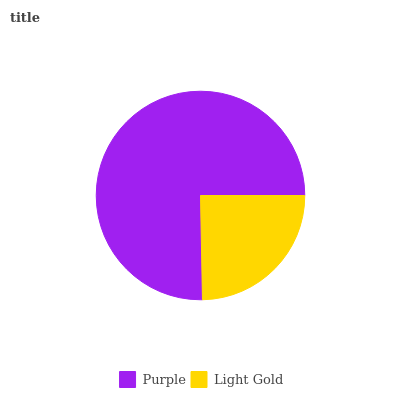Is Light Gold the minimum?
Answer yes or no. Yes. Is Purple the maximum?
Answer yes or no. Yes. Is Light Gold the maximum?
Answer yes or no. No. Is Purple greater than Light Gold?
Answer yes or no. Yes. Is Light Gold less than Purple?
Answer yes or no. Yes. Is Light Gold greater than Purple?
Answer yes or no. No. Is Purple less than Light Gold?
Answer yes or no. No. Is Purple the high median?
Answer yes or no. Yes. Is Light Gold the low median?
Answer yes or no. Yes. Is Light Gold the high median?
Answer yes or no. No. Is Purple the low median?
Answer yes or no. No. 